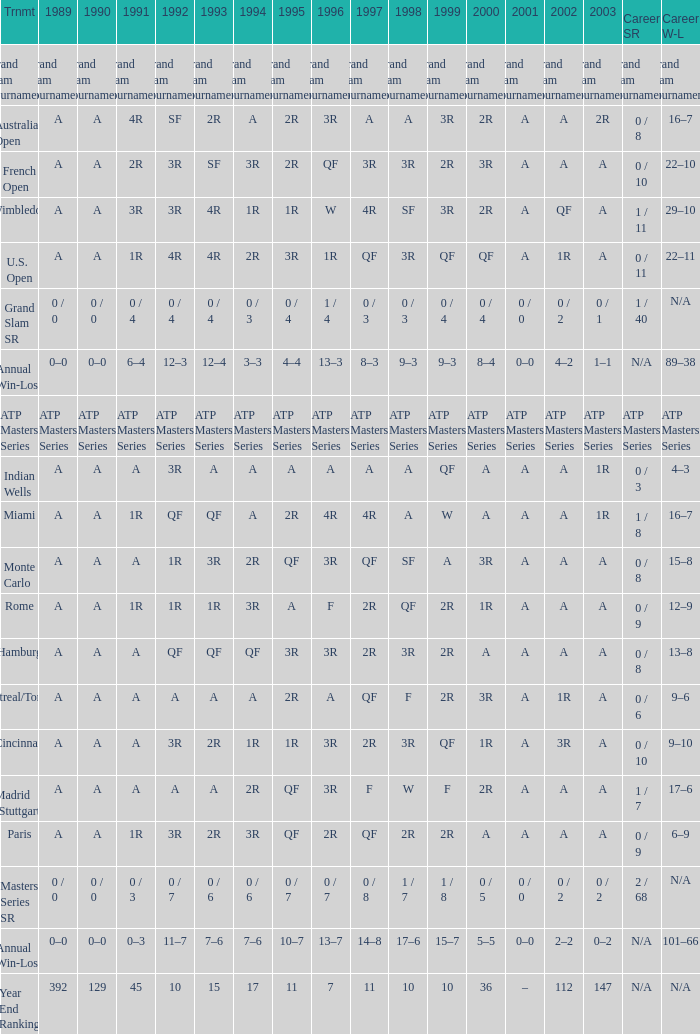What was the 1997 value when 2002 was A and 2003 was 1R? A, 4R. 